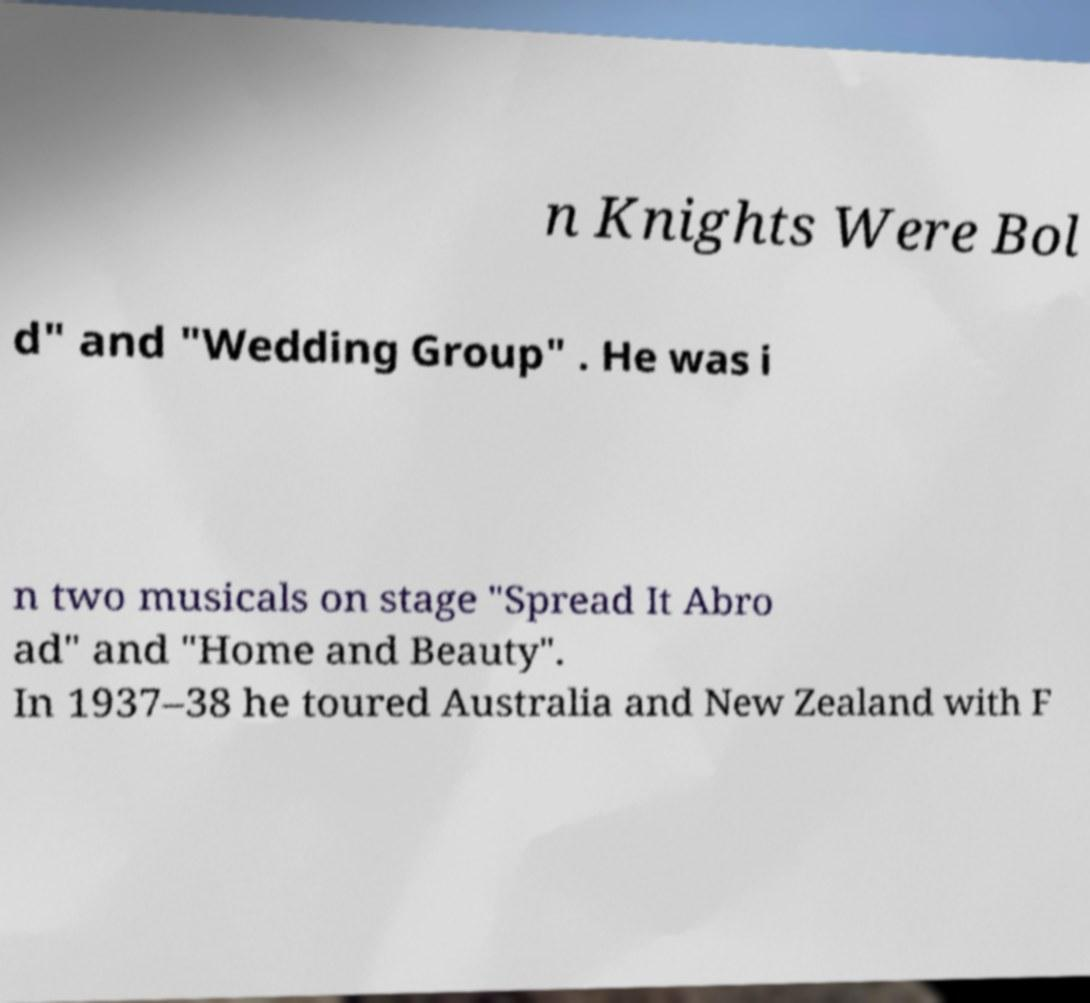Can you read and provide the text displayed in the image?This photo seems to have some interesting text. Can you extract and type it out for me? n Knights Were Bol d" and "Wedding Group" . He was i n two musicals on stage "Spread It Abro ad" and "Home and Beauty". In 1937–38 he toured Australia and New Zealand with F 